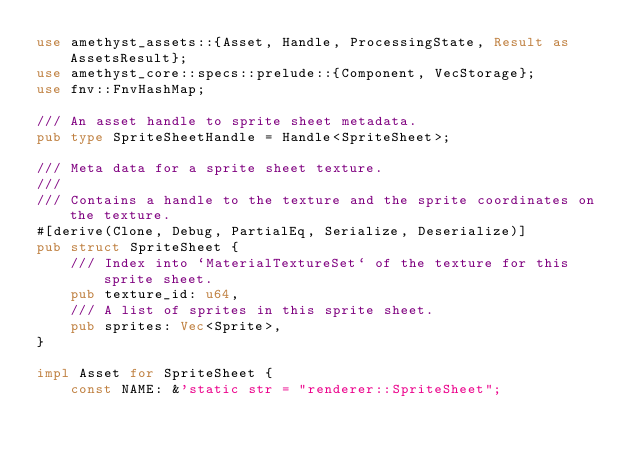Convert code to text. <code><loc_0><loc_0><loc_500><loc_500><_Rust_>use amethyst_assets::{Asset, Handle, ProcessingState, Result as AssetsResult};
use amethyst_core::specs::prelude::{Component, VecStorage};
use fnv::FnvHashMap;

/// An asset handle to sprite sheet metadata.
pub type SpriteSheetHandle = Handle<SpriteSheet>;

/// Meta data for a sprite sheet texture.
///
/// Contains a handle to the texture and the sprite coordinates on the texture.
#[derive(Clone, Debug, PartialEq, Serialize, Deserialize)]
pub struct SpriteSheet {
    /// Index into `MaterialTextureSet` of the texture for this sprite sheet.
    pub texture_id: u64,
    /// A list of sprites in this sprite sheet.
    pub sprites: Vec<Sprite>,
}

impl Asset for SpriteSheet {
    const NAME: &'static str = "renderer::SpriteSheet";</code> 